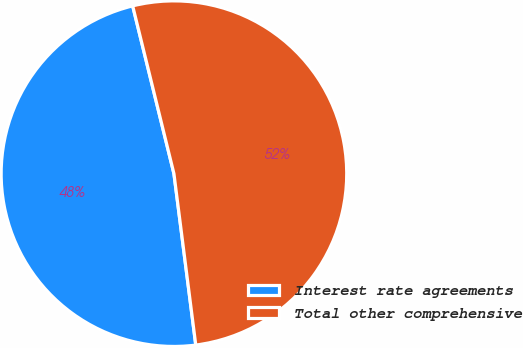<chart> <loc_0><loc_0><loc_500><loc_500><pie_chart><fcel>Interest rate agreements<fcel>Total other comprehensive<nl><fcel>48.18%<fcel>51.82%<nl></chart> 